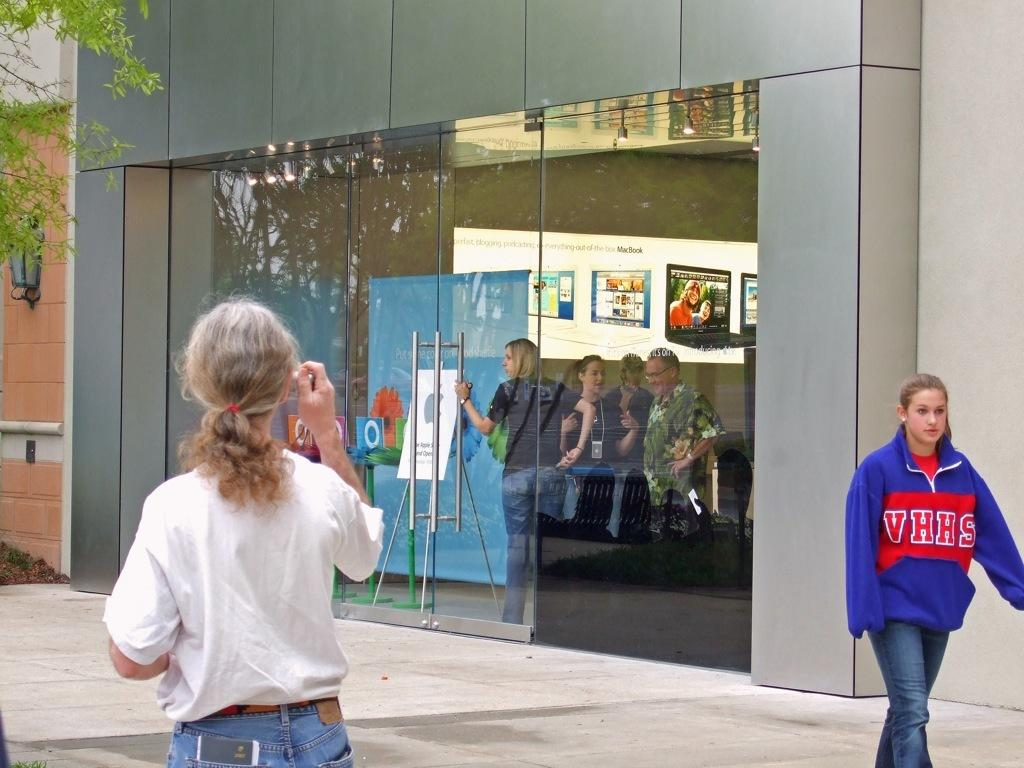<image>
Provide a brief description of the given image. The blue hoodie has the letters VHHS on it 